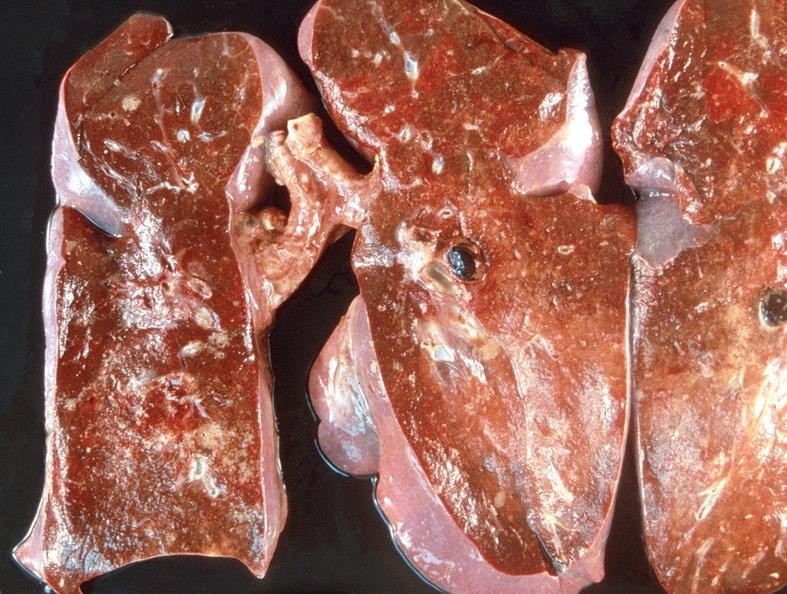what is present?
Answer the question using a single word or phrase. Respiratory 